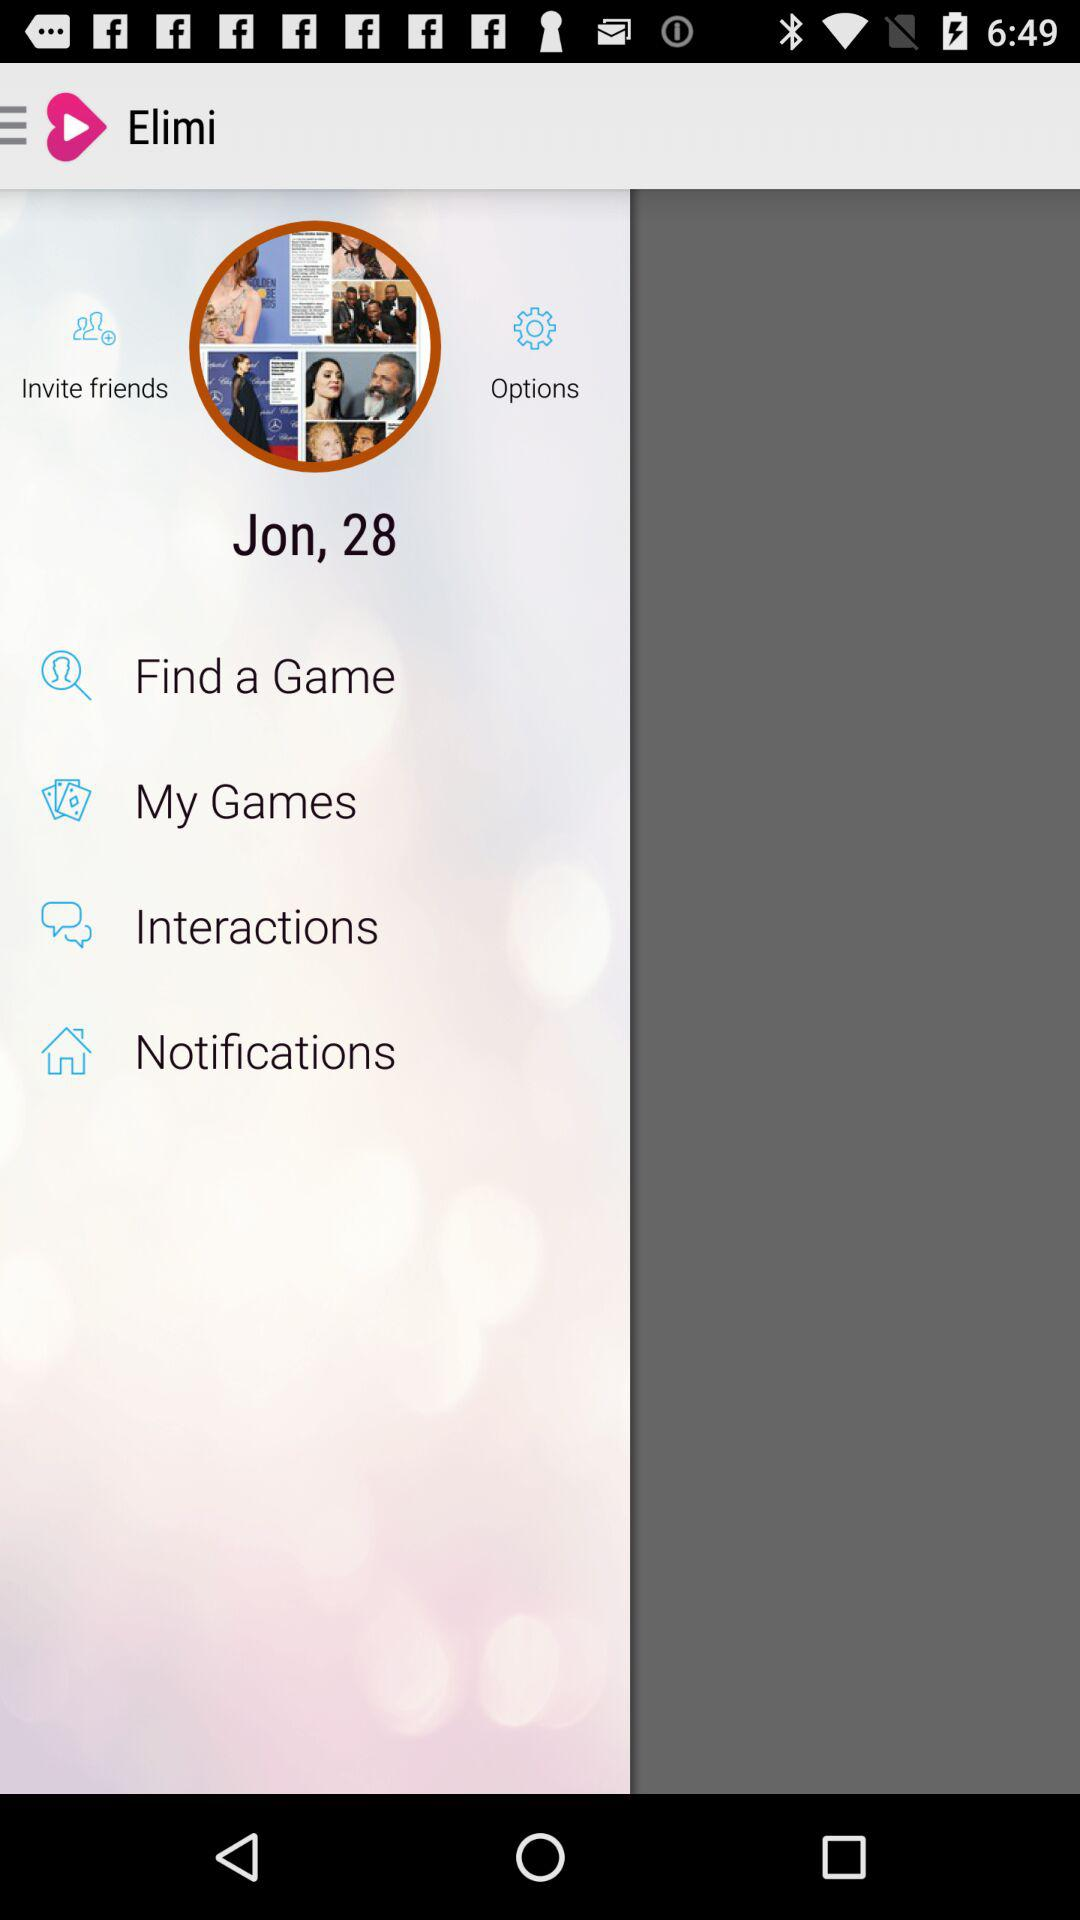What is the user name? The user name is Jon. 